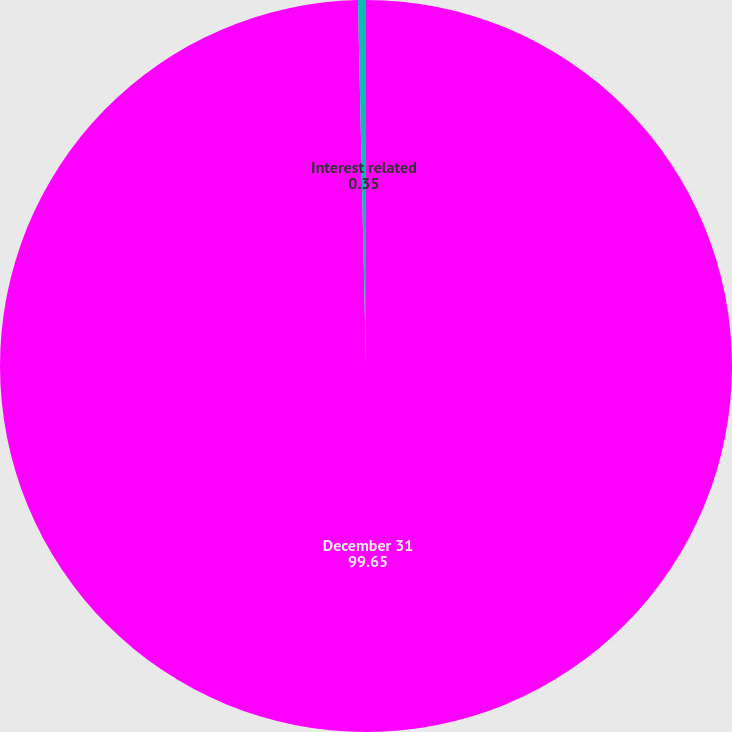Convert chart. <chart><loc_0><loc_0><loc_500><loc_500><pie_chart><fcel>December 31<fcel>Interest related<nl><fcel>99.65%<fcel>0.35%<nl></chart> 